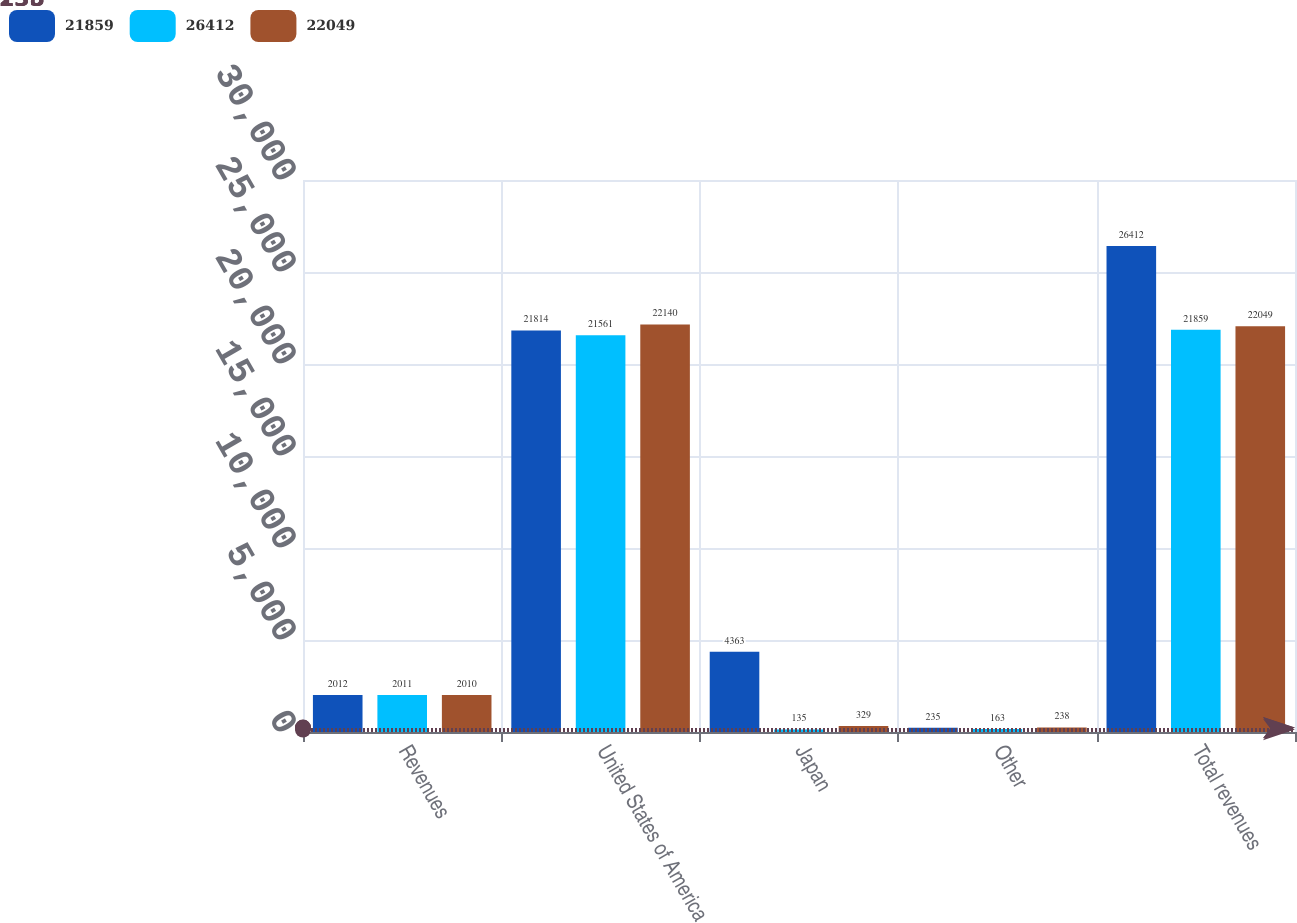Convert chart to OTSL. <chart><loc_0><loc_0><loc_500><loc_500><stacked_bar_chart><ecel><fcel>Revenues<fcel>United States of America<fcel>Japan<fcel>Other<fcel>Total revenues<nl><fcel>21859<fcel>2012<fcel>21814<fcel>4363<fcel>235<fcel>26412<nl><fcel>26412<fcel>2011<fcel>21561<fcel>135<fcel>163<fcel>21859<nl><fcel>22049<fcel>2010<fcel>22140<fcel>329<fcel>238<fcel>22049<nl></chart> 